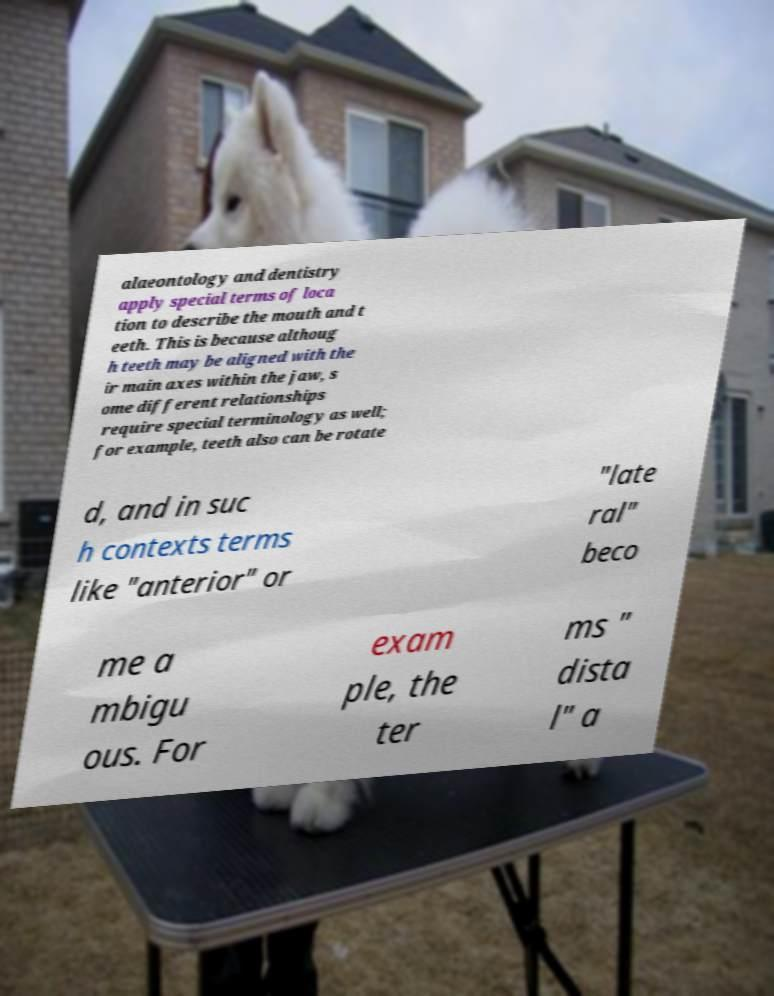What messages or text are displayed in this image? I need them in a readable, typed format. alaeontology and dentistry apply special terms of loca tion to describe the mouth and t eeth. This is because althoug h teeth may be aligned with the ir main axes within the jaw, s ome different relationships require special terminology as well; for example, teeth also can be rotate d, and in suc h contexts terms like "anterior" or "late ral" beco me a mbigu ous. For exam ple, the ter ms " dista l" a 